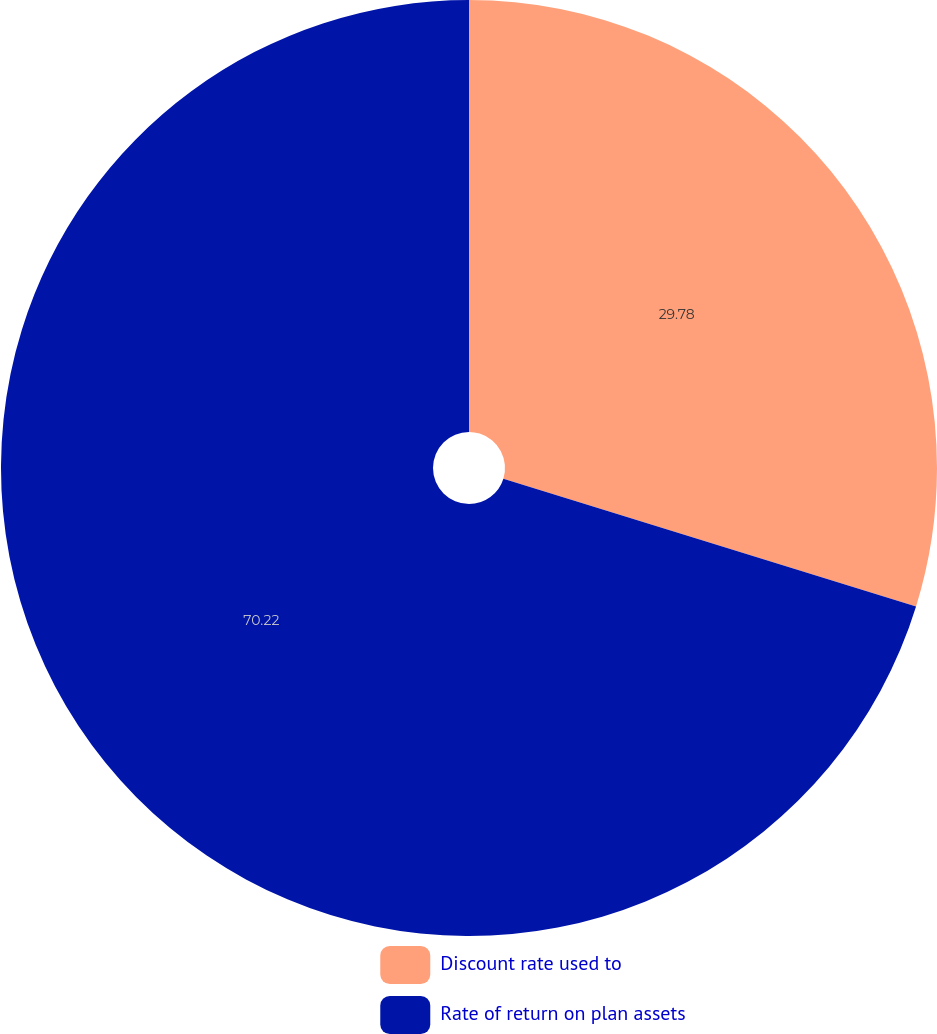Convert chart. <chart><loc_0><loc_0><loc_500><loc_500><pie_chart><fcel>Discount rate used to<fcel>Rate of return on plan assets<nl><fcel>29.78%<fcel>70.22%<nl></chart> 